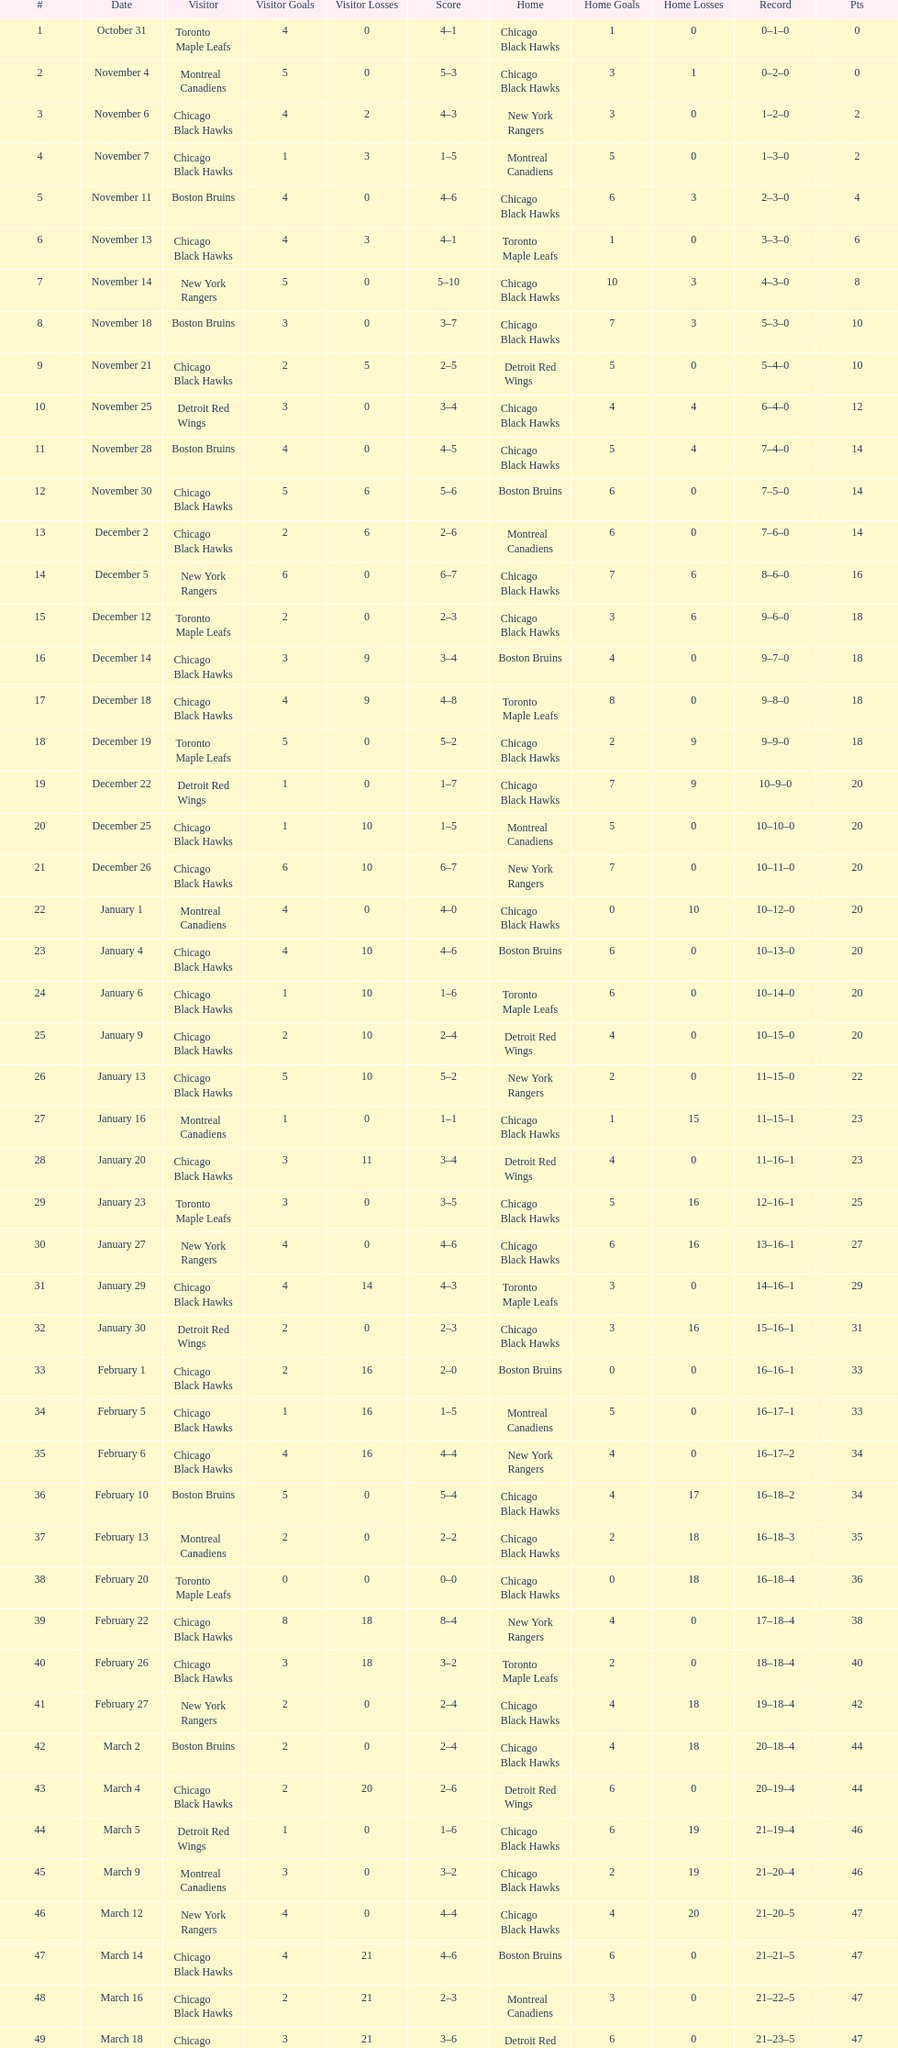What is was the difference in score in the december 19th win? 3. 